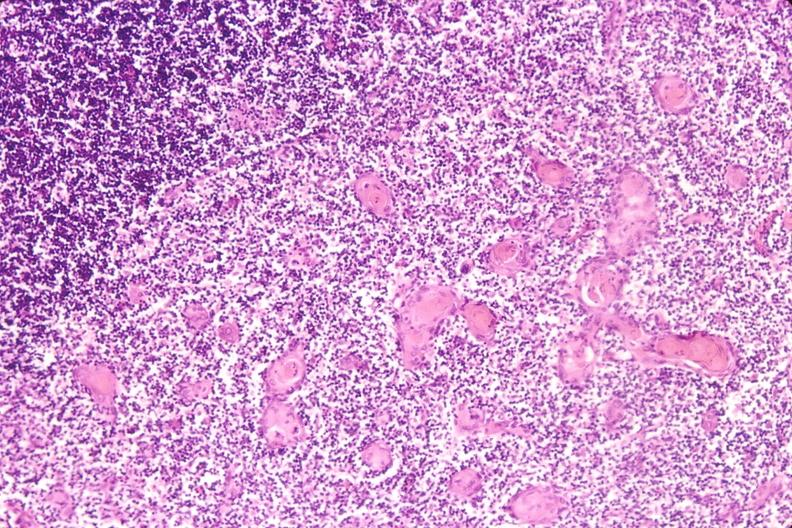how do stress induce involution in baby?
Answer the question using a single word or phrase. Hyaline membrane disease 